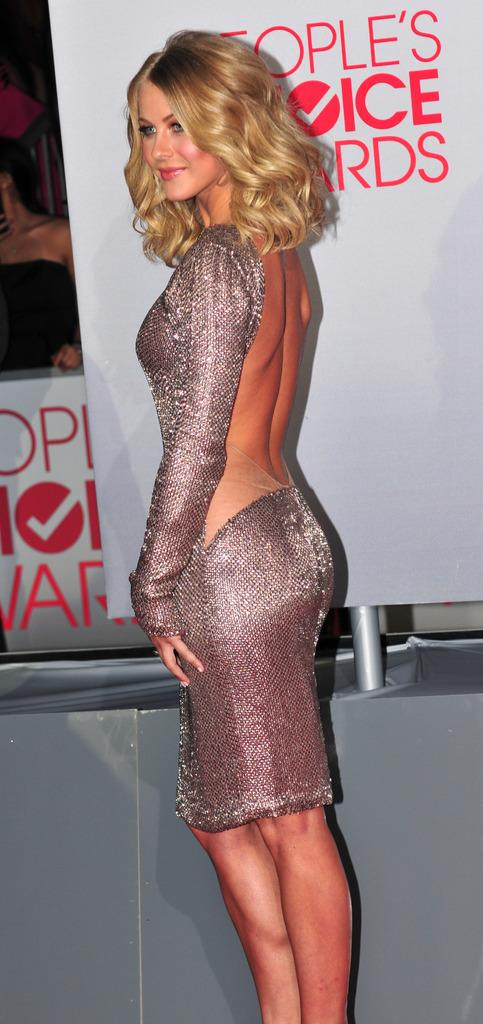What is the main subject of the image? There is a lady standing in the image. What can be seen in the background of the image? There is a banner with a pole in the background. Are there any additional banners visible in the image? Yes, there is another banner visible behind the first banner. What type of flowers can be seen growing around the lady in the image? There are no flowers visible in the image; it only features a lady standing and banners in the background. 